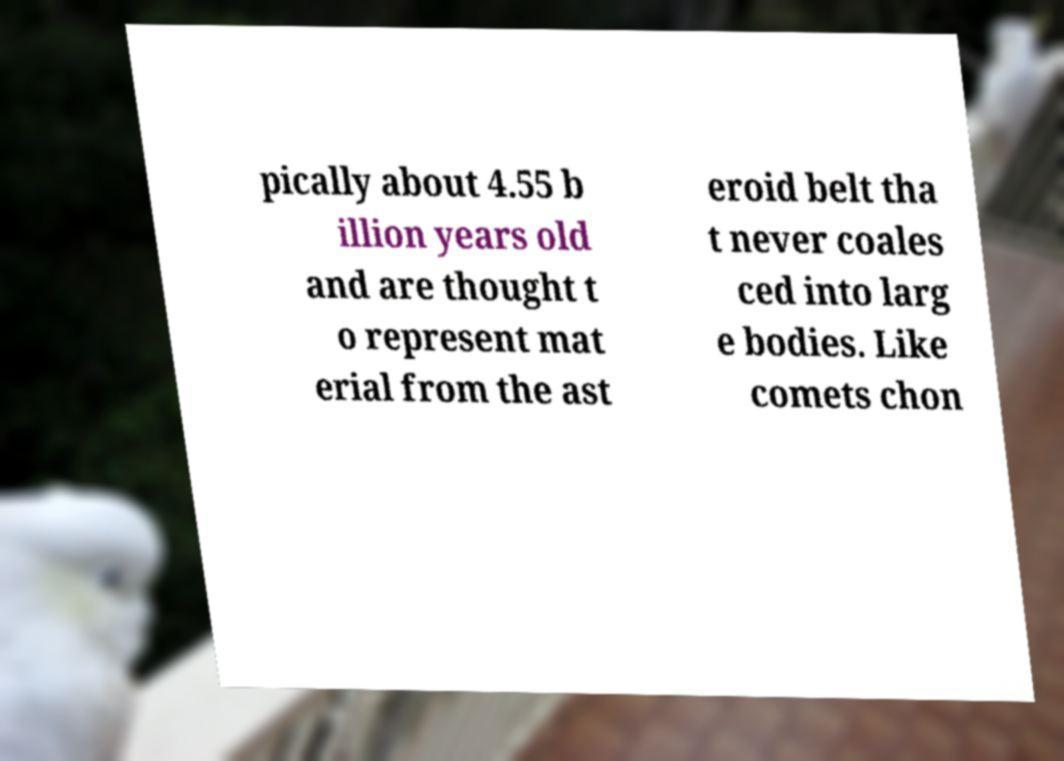What messages or text are displayed in this image? I need them in a readable, typed format. pically about 4.55 b illion years old and are thought t o represent mat erial from the ast eroid belt tha t never coales ced into larg e bodies. Like comets chon 